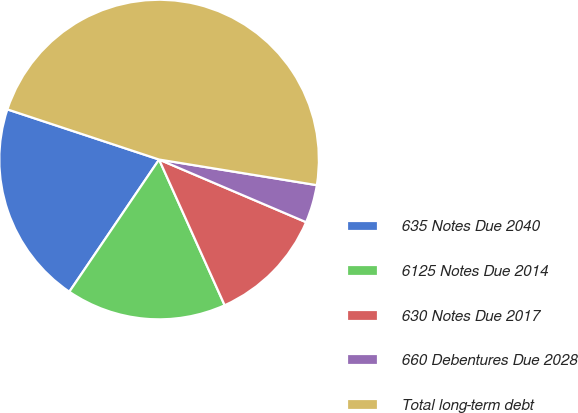<chart> <loc_0><loc_0><loc_500><loc_500><pie_chart><fcel>635 Notes Due 2040<fcel>6125 Notes Due 2014<fcel>630 Notes Due 2017<fcel>660 Debentures Due 2028<fcel>Total long-term debt<nl><fcel>20.59%<fcel>16.22%<fcel>11.86%<fcel>3.85%<fcel>47.48%<nl></chart> 